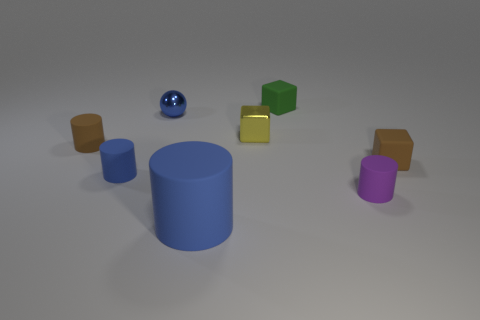Subtract all tiny cylinders. How many cylinders are left? 1 Subtract all blue cubes. How many blue cylinders are left? 2 Subtract all purple cylinders. How many cylinders are left? 3 Add 2 small shiny objects. How many objects exist? 10 Subtract 2 cylinders. How many cylinders are left? 2 Subtract all balls. How many objects are left? 7 Subtract all small cyan metal cylinders. Subtract all small blue balls. How many objects are left? 7 Add 8 brown cubes. How many brown cubes are left? 9 Add 3 big gray metallic objects. How many big gray metallic objects exist? 3 Subtract 1 brown cylinders. How many objects are left? 7 